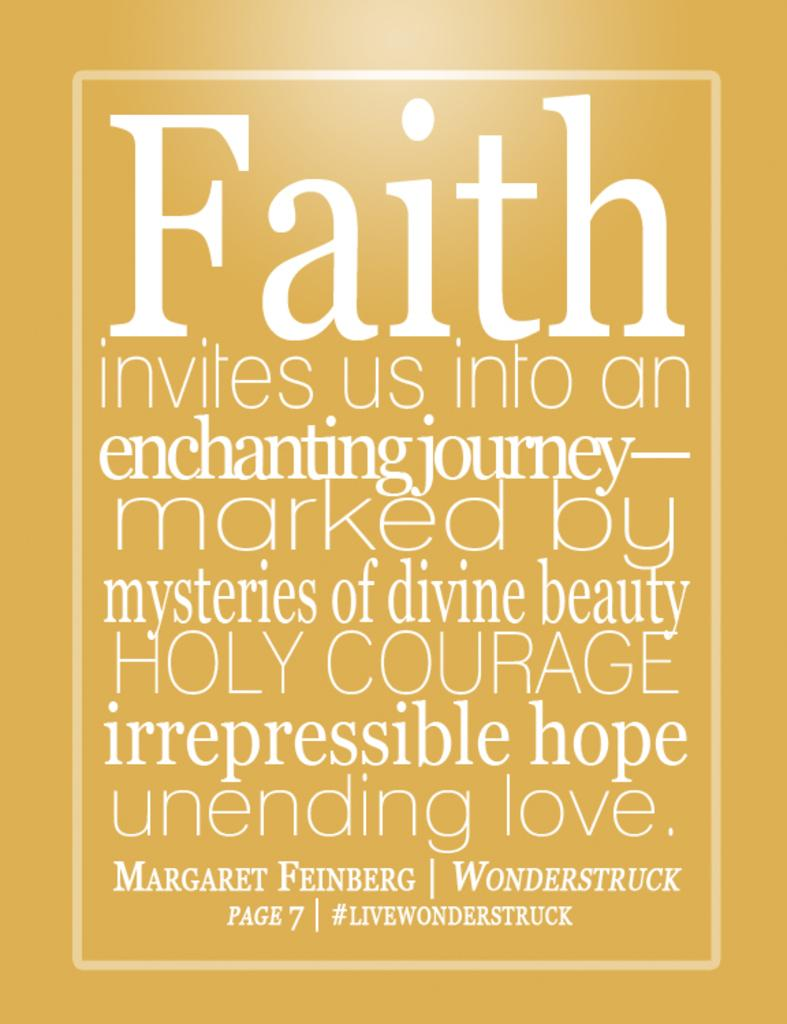<image>
Describe the image concisely. Orange background with a quote that starts with the word "Faith". 